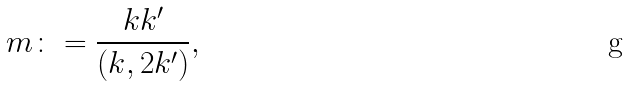<formula> <loc_0><loc_0><loc_500><loc_500>m \colon = \frac { k k ^ { \prime } } { ( k , 2 k ^ { \prime } ) } ,</formula> 